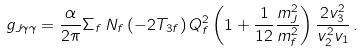Convert formula to latex. <formula><loc_0><loc_0><loc_500><loc_500>g _ { J \gamma \gamma } = \frac { \alpha } { 2 \pi } \Sigma _ { f } \, N _ { f } \, ( - 2 T _ { 3 f } ) \, Q _ { f } ^ { 2 } \left ( 1 + \frac { 1 } { 1 2 } \frac { m _ { J } ^ { 2 } } { m _ { f } ^ { 2 } } \right ) \frac { 2 v _ { 3 } ^ { 2 } } { v _ { 2 } ^ { 2 } v _ { 1 } } \, .</formula> 